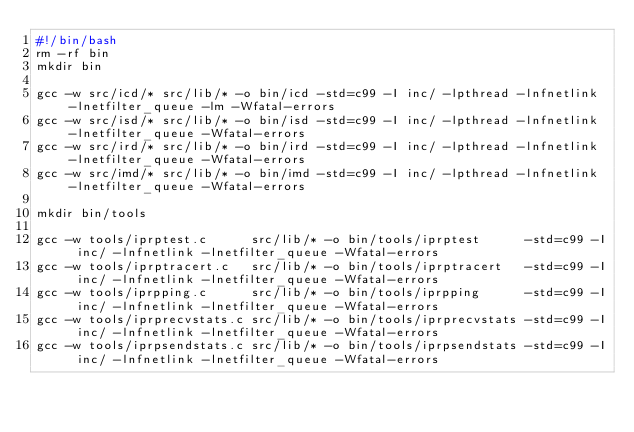<code> <loc_0><loc_0><loc_500><loc_500><_Bash_>#!/bin/bash
rm -rf bin
mkdir bin

gcc -w src/icd/* src/lib/* -o bin/icd -std=c99 -I inc/ -lpthread -lnfnetlink -lnetfilter_queue -lm -Wfatal-errors
gcc -w src/isd/* src/lib/* -o bin/isd -std=c99 -I inc/ -lpthread -lnfnetlink -lnetfilter_queue -Wfatal-errors
gcc -w src/ird/* src/lib/* -o bin/ird -std=c99 -I inc/ -lpthread -lnfnetlink -lnetfilter_queue -Wfatal-errors
gcc -w src/imd/* src/lib/* -o bin/imd -std=c99 -I inc/ -lpthread -lnfnetlink -lnetfilter_queue -Wfatal-errors

mkdir bin/tools

gcc -w tools/iprptest.c      src/lib/* -o bin/tools/iprptest      -std=c99 -I inc/ -lnfnetlink -lnetfilter_queue -Wfatal-errors
gcc -w tools/iprptracert.c   src/lib/* -o bin/tools/iprptracert   -std=c99 -I inc/ -lnfnetlink -lnetfilter_queue -Wfatal-errors
gcc -w tools/iprpping.c      src/lib/* -o bin/tools/iprpping      -std=c99 -I inc/ -lnfnetlink -lnetfilter_queue -Wfatal-errors
gcc -w tools/iprprecvstats.c src/lib/* -o bin/tools/iprprecvstats -std=c99 -I inc/ -lnfnetlink -lnetfilter_queue -Wfatal-errors
gcc -w tools/iprpsendstats.c src/lib/* -o bin/tools/iprpsendstats -std=c99 -I inc/ -lnfnetlink -lnetfilter_queue -Wfatal-errors</code> 